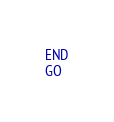<code> <loc_0><loc_0><loc_500><loc_500><_SQL_>END
GO</code> 